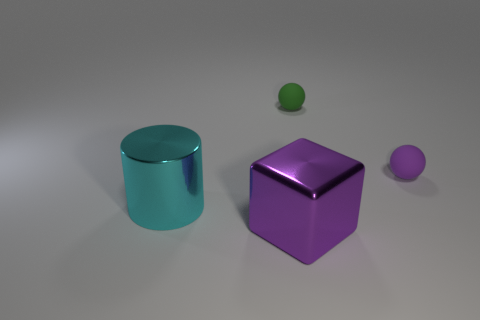Add 3 big blue metal cylinders. How many objects exist? 7 Subtract all blocks. How many objects are left? 3 Subtract all rubber spheres. Subtract all small matte objects. How many objects are left? 0 Add 4 large purple shiny things. How many large purple shiny things are left? 5 Add 1 small matte things. How many small matte things exist? 3 Subtract 0 cyan blocks. How many objects are left? 4 